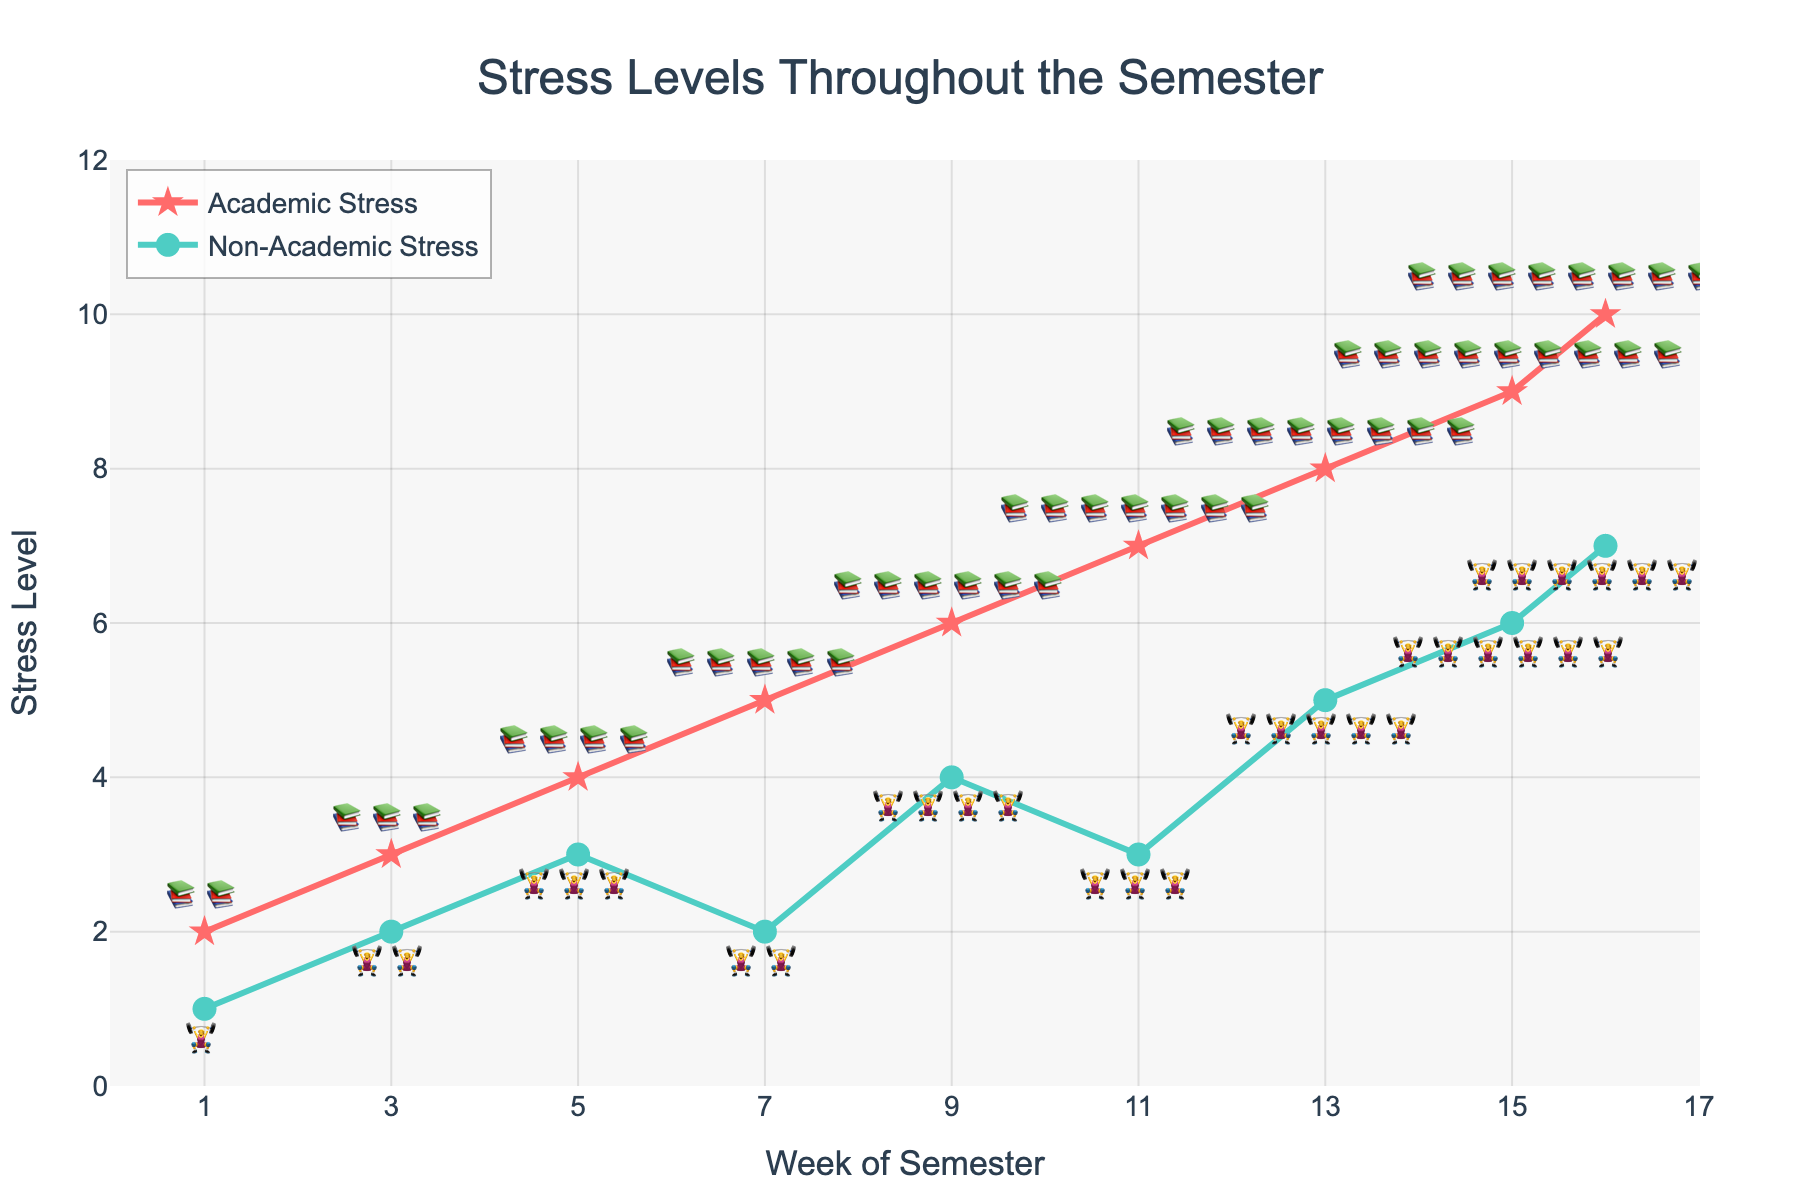What's the title of the chart? The title of the chart is displayed at the top center.
Answer: Stress Levels Throughout the Semester What symbol is used to represent Academic Stress on the chart? The symbol for Academic Stress can be identified next to the markers in the Academic Stress line.
Answer: 📚 How many weeks are represented on the X-axis in the chart? The number of data points plotted on the X-axis indicates the total weeks in the chart. Count the number of tick marks.
Answer: 9 At which week does Non-Academic Stress start to increase significantly? Identify the week where the slope of the Non-Academic Stress line first increases noticeably.
Answer: Week 5 What's the maximum level of Academic Stress shown in the chart? Look for the highest point on the Academic Stress line on the Y-axis.
Answer: 10 During which week is the difference between Academic Stress and Non-Academic Stress the greatest? Calculate the differences for each week and look for the week with the largest difference.
Answer: Week 16 Which type of stress remains steady for a longer period during the semester? Compare the slopes of both the Academic Stress and Non-Academic Stress lines to see which one stays more level over time.
Answer: Non-Academic Stress By how much does Academic Stress increase from Week 7 to Week 11? Identify the stress levels at Week 7 and Week 11 and subtract the Week 7 value from the Week 11 value.
Answer: 2 Which week’s Academic Stress level is equivalent to the Non-Academic Stress level in Week 16? Look for the week where the Academic Stress level matches the Non-Academic Stress level at Week 16, which is 7.
Answer: None 